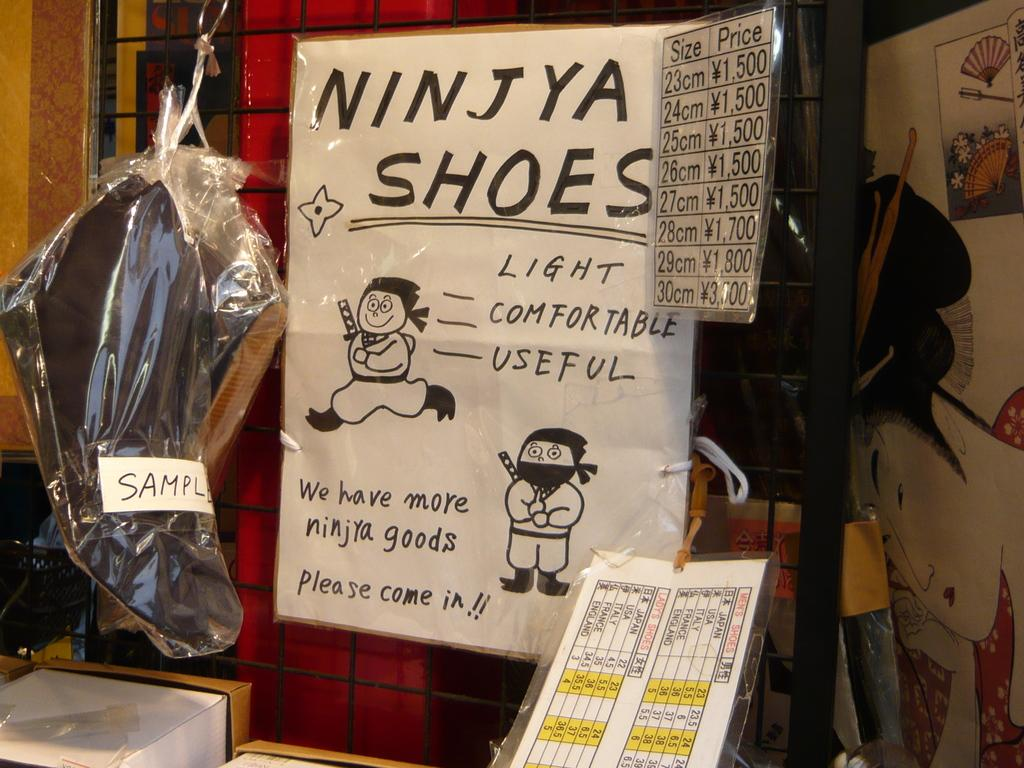<image>
Describe the image concisely. A sign with cartoons on it says "we have more ninjya goods." 